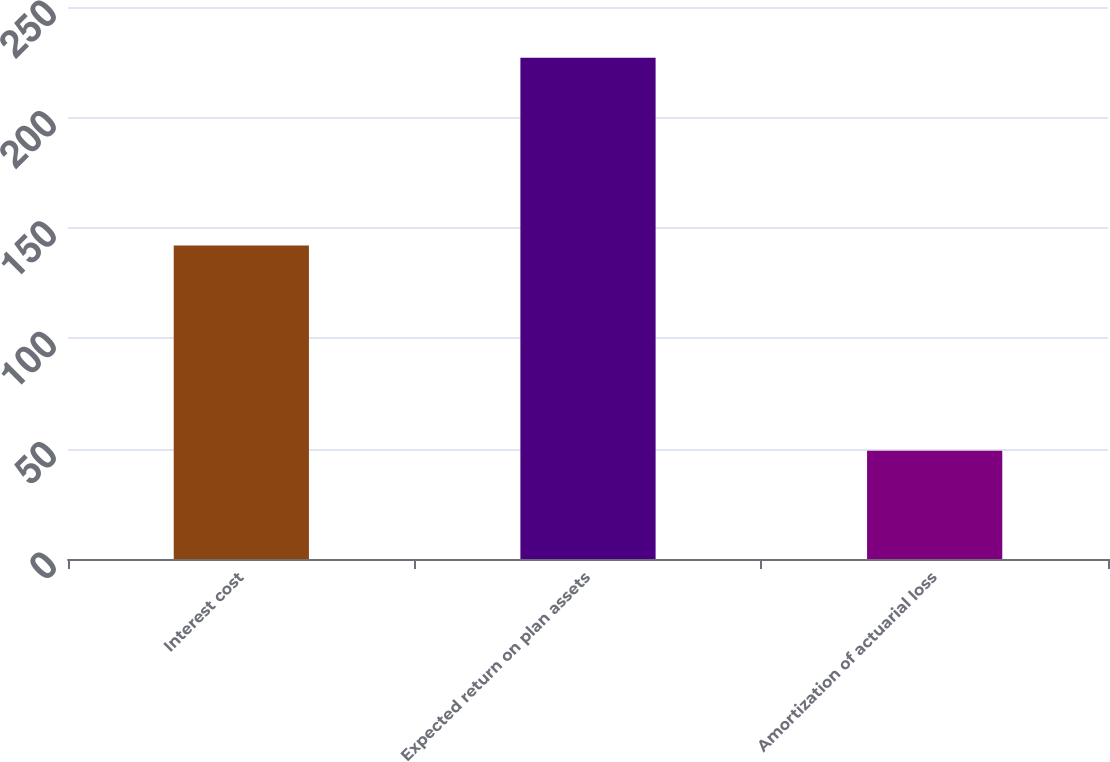<chart> <loc_0><loc_0><loc_500><loc_500><bar_chart><fcel>Interest cost<fcel>Expected return on plan assets<fcel>Amortization of actuarial loss<nl><fcel>142<fcel>227<fcel>49<nl></chart> 